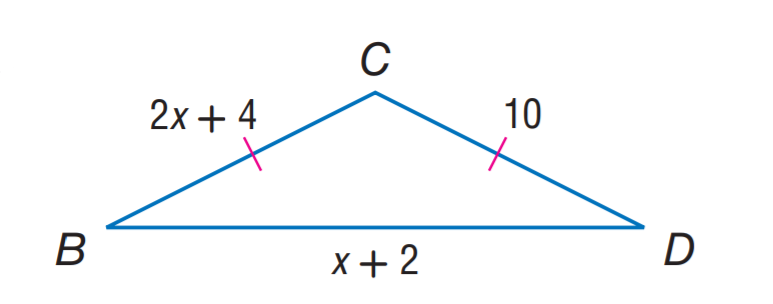Answer the mathemtical geometry problem and directly provide the correct option letter.
Question: Find x.
Choices: A: 2 B: 3 C: 4 D: 5 B 